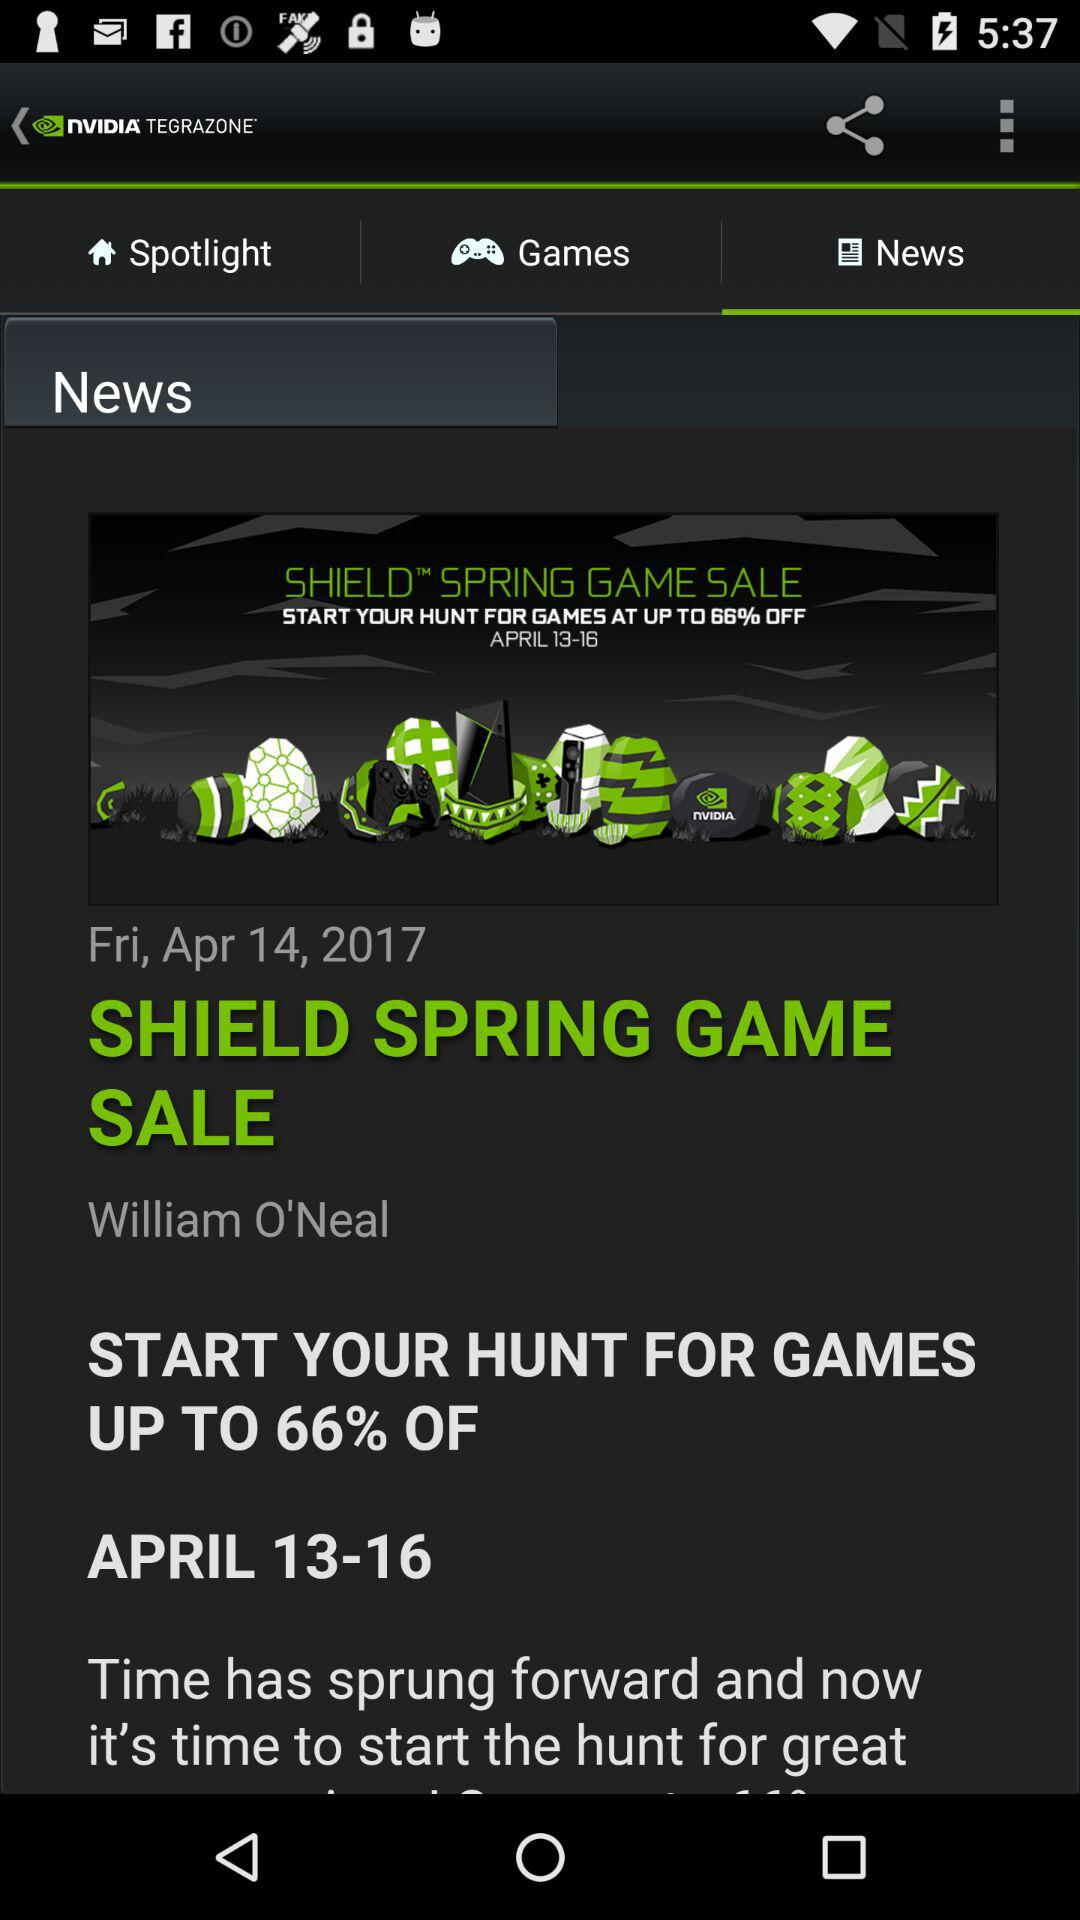What is the shown author's name? The shown author's name is William O'Neal. 